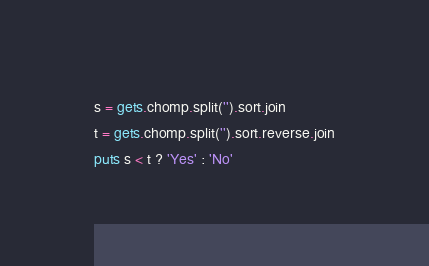Convert code to text. <code><loc_0><loc_0><loc_500><loc_500><_Ruby_>s = gets.chomp.split('').sort.join
t = gets.chomp.split('').sort.reverse.join
puts s < t ? 'Yes' : 'No'</code> 